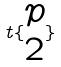Convert formula to latex. <formula><loc_0><loc_0><loc_500><loc_500>t \{ \begin{matrix} p \\ 2 \end{matrix} \}</formula> 